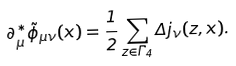Convert formula to latex. <formula><loc_0><loc_0><loc_500><loc_500>\partial _ { \mu } ^ { \ast } \tilde { \phi } _ { \mu \nu } ( x ) = \frac { 1 } { 2 } \sum _ { z \in \Gamma _ { 4 } } \Delta j _ { \nu } ( z , x ) .</formula> 